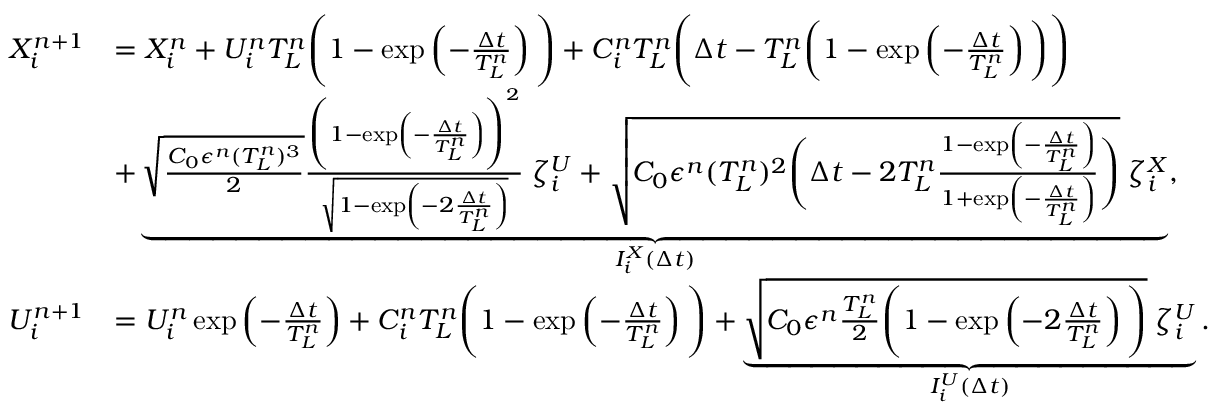Convert formula to latex. <formula><loc_0><loc_0><loc_500><loc_500>\begin{array} { r l } { X _ { i } ^ { n + 1 } } & { = X _ { i } ^ { n } + U _ { i } ^ { n } T _ { L } ^ { n } \left ( 1 - \exp \left ( - \frac { \Delta t } { T _ { L } ^ { n } } \right ) \right ) + C _ { i } ^ { n } T _ { L } ^ { n } \left ( \Delta t - T _ { L } ^ { n } \left ( 1 - \exp \left ( - \frac { \Delta t } { T _ { L } ^ { n } } \right ) \right ) \right ) } \\ & { + \underbrace { \sqrt { \frac { C _ { 0 } \epsilon ^ { n } ( T _ { L } ^ { n } ) ^ { 3 } } { 2 } } \frac { \left ( 1 - \exp \left ( - \frac { \Delta t } { T _ { L } ^ { n } } \right ) \right ) ^ { 2 } } { \sqrt { 1 - \exp \left ( - 2 \frac { \Delta t } { T _ { L } ^ { n } } \right ) } } \, \zeta _ { i } ^ { U } + \sqrt { C _ { 0 } \epsilon ^ { n } ( T _ { L } ^ { n } ) ^ { 2 } \left ( \Delta t - 2 T _ { L } ^ { n } \frac { 1 - \exp \left ( - \frac { \Delta t } { T _ { L } ^ { n } } \right ) } { 1 + \exp \left ( - \frac { \Delta t } { T _ { L } ^ { n } } \right ) } \right ) } \, \zeta _ { i } ^ { X } } _ { I _ { i } ^ { X } ( \Delta t ) } , } \\ { U _ { i } ^ { n + 1 } } & { = U _ { i } ^ { n } \exp \left ( - \frac { \Delta t } { T _ { L } ^ { n } } \right ) + C _ { i } ^ { n } T _ { L } ^ { n } \left ( 1 - \exp \left ( - \frac { \Delta t } { T _ { L } ^ { n } } \right ) \right ) + \underbrace { \sqrt { C _ { 0 } \epsilon ^ { n } \frac { T _ { L } ^ { n } } { 2 } \left ( 1 - \exp \left ( - 2 \frac { \Delta t } { T _ { L } ^ { n } } \right ) \right ) } \, \zeta _ { i } ^ { U } } _ { I _ { i } ^ { U } ( \Delta t ) } . } \end{array}</formula> 